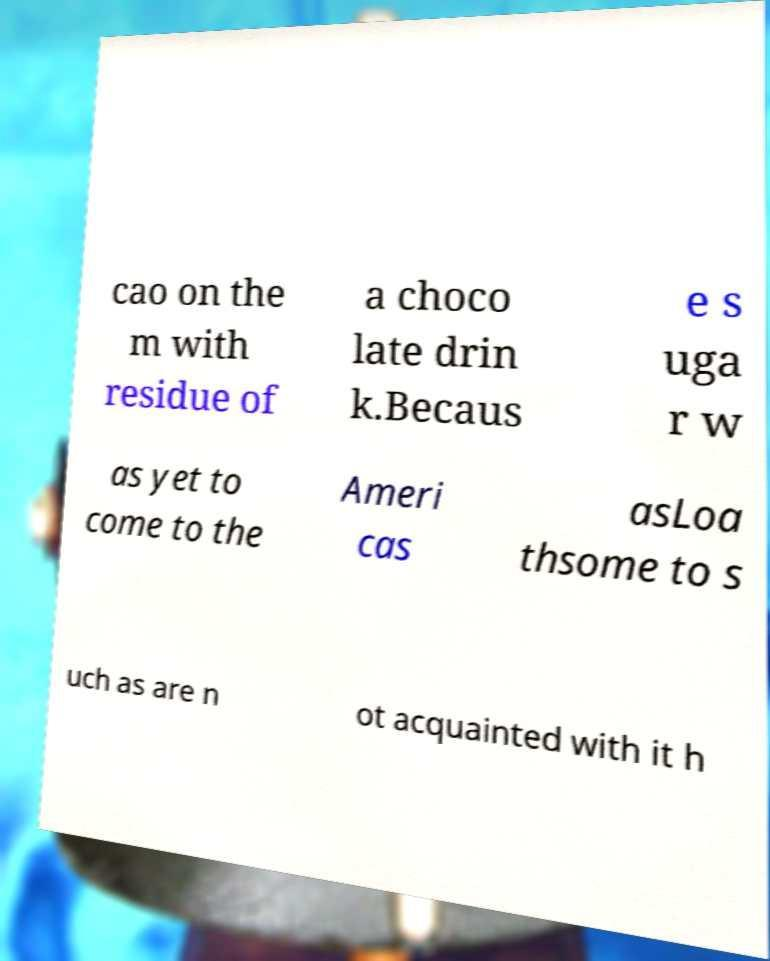Could you extract and type out the text from this image? cao on the m with residue of a choco late drin k.Becaus e s uga r w as yet to come to the Ameri cas asLoa thsome to s uch as are n ot acquainted with it h 